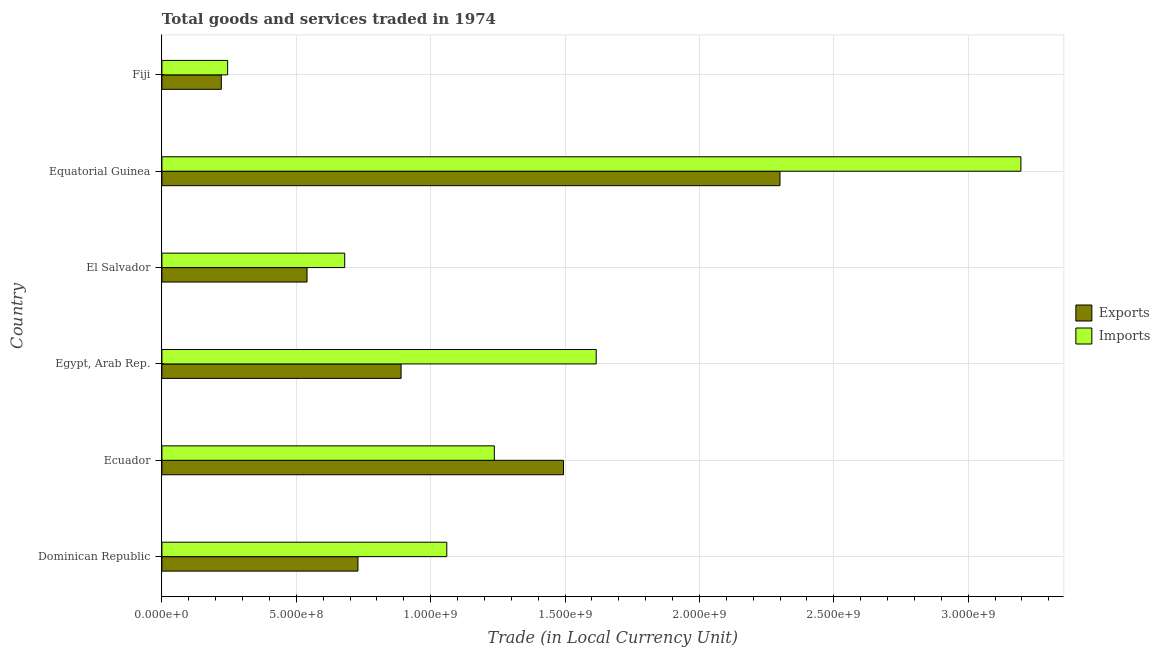How many groups of bars are there?
Make the answer very short. 6. Are the number of bars per tick equal to the number of legend labels?
Offer a terse response. Yes. Are the number of bars on each tick of the Y-axis equal?
Your answer should be very brief. Yes. How many bars are there on the 3rd tick from the bottom?
Provide a short and direct response. 2. What is the label of the 5th group of bars from the top?
Give a very brief answer. Ecuador. What is the export of goods and services in Ecuador?
Your answer should be very brief. 1.49e+09. Across all countries, what is the maximum imports of goods and services?
Offer a very short reply. 3.20e+09. Across all countries, what is the minimum imports of goods and services?
Keep it short and to the point. 2.45e+08. In which country was the export of goods and services maximum?
Provide a succinct answer. Equatorial Guinea. In which country was the imports of goods and services minimum?
Provide a short and direct response. Fiji. What is the total export of goods and services in the graph?
Offer a terse response. 6.17e+09. What is the difference between the imports of goods and services in Egypt, Arab Rep. and that in El Salvador?
Provide a short and direct response. 9.36e+08. What is the difference between the imports of goods and services in Equatorial Guinea and the export of goods and services in El Salvador?
Provide a succinct answer. 2.66e+09. What is the average export of goods and services per country?
Make the answer very short. 1.03e+09. What is the difference between the export of goods and services and imports of goods and services in Dominican Republic?
Give a very brief answer. -3.30e+08. What is the ratio of the export of goods and services in Egypt, Arab Rep. to that in Fiji?
Provide a succinct answer. 4.03. What is the difference between the highest and the second highest export of goods and services?
Make the answer very short. 8.06e+08. What is the difference between the highest and the lowest imports of goods and services?
Provide a succinct answer. 2.95e+09. What does the 2nd bar from the top in Equatorial Guinea represents?
Offer a very short reply. Exports. What does the 1st bar from the bottom in El Salvador represents?
Keep it short and to the point. Exports. How many bars are there?
Your response must be concise. 12. How many countries are there in the graph?
Offer a terse response. 6. What is the difference between two consecutive major ticks on the X-axis?
Ensure brevity in your answer.  5.00e+08. Are the values on the major ticks of X-axis written in scientific E-notation?
Offer a terse response. Yes. Does the graph contain grids?
Your answer should be very brief. Yes. Where does the legend appear in the graph?
Make the answer very short. Center right. How many legend labels are there?
Keep it short and to the point. 2. What is the title of the graph?
Your answer should be very brief. Total goods and services traded in 1974. What is the label or title of the X-axis?
Keep it short and to the point. Trade (in Local Currency Unit). What is the Trade (in Local Currency Unit) of Exports in Dominican Republic?
Your answer should be very brief. 7.30e+08. What is the Trade (in Local Currency Unit) of Imports in Dominican Republic?
Make the answer very short. 1.06e+09. What is the Trade (in Local Currency Unit) in Exports in Ecuador?
Keep it short and to the point. 1.49e+09. What is the Trade (in Local Currency Unit) of Imports in Ecuador?
Make the answer very short. 1.24e+09. What is the Trade (in Local Currency Unit) of Exports in Egypt, Arab Rep.?
Keep it short and to the point. 8.90e+08. What is the Trade (in Local Currency Unit) of Imports in Egypt, Arab Rep.?
Offer a very short reply. 1.62e+09. What is the Trade (in Local Currency Unit) of Exports in El Salvador?
Make the answer very short. 5.40e+08. What is the Trade (in Local Currency Unit) of Imports in El Salvador?
Your answer should be very brief. 6.80e+08. What is the Trade (in Local Currency Unit) of Exports in Equatorial Guinea?
Keep it short and to the point. 2.30e+09. What is the Trade (in Local Currency Unit) in Imports in Equatorial Guinea?
Make the answer very short. 3.20e+09. What is the Trade (in Local Currency Unit) of Exports in Fiji?
Ensure brevity in your answer.  2.21e+08. What is the Trade (in Local Currency Unit) in Imports in Fiji?
Your answer should be very brief. 2.45e+08. Across all countries, what is the maximum Trade (in Local Currency Unit) of Exports?
Give a very brief answer. 2.30e+09. Across all countries, what is the maximum Trade (in Local Currency Unit) of Imports?
Your answer should be compact. 3.20e+09. Across all countries, what is the minimum Trade (in Local Currency Unit) of Exports?
Make the answer very short. 2.21e+08. Across all countries, what is the minimum Trade (in Local Currency Unit) in Imports?
Your answer should be compact. 2.45e+08. What is the total Trade (in Local Currency Unit) in Exports in the graph?
Your answer should be compact. 6.17e+09. What is the total Trade (in Local Currency Unit) of Imports in the graph?
Provide a short and direct response. 8.03e+09. What is the difference between the Trade (in Local Currency Unit) of Exports in Dominican Republic and that in Ecuador?
Your answer should be compact. -7.65e+08. What is the difference between the Trade (in Local Currency Unit) in Imports in Dominican Republic and that in Ecuador?
Give a very brief answer. -1.77e+08. What is the difference between the Trade (in Local Currency Unit) of Exports in Dominican Republic and that in Egypt, Arab Rep.?
Ensure brevity in your answer.  -1.60e+08. What is the difference between the Trade (in Local Currency Unit) in Imports in Dominican Republic and that in Egypt, Arab Rep.?
Keep it short and to the point. -5.56e+08. What is the difference between the Trade (in Local Currency Unit) of Exports in Dominican Republic and that in El Salvador?
Your response must be concise. 1.89e+08. What is the difference between the Trade (in Local Currency Unit) in Imports in Dominican Republic and that in El Salvador?
Ensure brevity in your answer.  3.80e+08. What is the difference between the Trade (in Local Currency Unit) in Exports in Dominican Republic and that in Equatorial Guinea?
Your answer should be very brief. -1.57e+09. What is the difference between the Trade (in Local Currency Unit) in Imports in Dominican Republic and that in Equatorial Guinea?
Provide a succinct answer. -2.14e+09. What is the difference between the Trade (in Local Currency Unit) in Exports in Dominican Republic and that in Fiji?
Provide a short and direct response. 5.08e+08. What is the difference between the Trade (in Local Currency Unit) of Imports in Dominican Republic and that in Fiji?
Give a very brief answer. 8.15e+08. What is the difference between the Trade (in Local Currency Unit) in Exports in Ecuador and that in Egypt, Arab Rep.?
Offer a very short reply. 6.04e+08. What is the difference between the Trade (in Local Currency Unit) in Imports in Ecuador and that in Egypt, Arab Rep.?
Your answer should be compact. -3.79e+08. What is the difference between the Trade (in Local Currency Unit) in Exports in Ecuador and that in El Salvador?
Make the answer very short. 9.54e+08. What is the difference between the Trade (in Local Currency Unit) of Imports in Ecuador and that in El Salvador?
Give a very brief answer. 5.57e+08. What is the difference between the Trade (in Local Currency Unit) in Exports in Ecuador and that in Equatorial Guinea?
Provide a succinct answer. -8.06e+08. What is the difference between the Trade (in Local Currency Unit) in Imports in Ecuador and that in Equatorial Guinea?
Your response must be concise. -1.96e+09. What is the difference between the Trade (in Local Currency Unit) in Exports in Ecuador and that in Fiji?
Your answer should be compact. 1.27e+09. What is the difference between the Trade (in Local Currency Unit) of Imports in Ecuador and that in Fiji?
Give a very brief answer. 9.92e+08. What is the difference between the Trade (in Local Currency Unit) of Exports in Egypt, Arab Rep. and that in El Salvador?
Ensure brevity in your answer.  3.50e+08. What is the difference between the Trade (in Local Currency Unit) in Imports in Egypt, Arab Rep. and that in El Salvador?
Offer a very short reply. 9.36e+08. What is the difference between the Trade (in Local Currency Unit) in Exports in Egypt, Arab Rep. and that in Equatorial Guinea?
Make the answer very short. -1.41e+09. What is the difference between the Trade (in Local Currency Unit) in Imports in Egypt, Arab Rep. and that in Equatorial Guinea?
Offer a very short reply. -1.58e+09. What is the difference between the Trade (in Local Currency Unit) of Exports in Egypt, Arab Rep. and that in Fiji?
Ensure brevity in your answer.  6.69e+08. What is the difference between the Trade (in Local Currency Unit) in Imports in Egypt, Arab Rep. and that in Fiji?
Provide a short and direct response. 1.37e+09. What is the difference between the Trade (in Local Currency Unit) in Exports in El Salvador and that in Equatorial Guinea?
Your response must be concise. -1.76e+09. What is the difference between the Trade (in Local Currency Unit) of Imports in El Salvador and that in Equatorial Guinea?
Offer a very short reply. -2.52e+09. What is the difference between the Trade (in Local Currency Unit) of Exports in El Salvador and that in Fiji?
Offer a terse response. 3.19e+08. What is the difference between the Trade (in Local Currency Unit) in Imports in El Salvador and that in Fiji?
Your response must be concise. 4.36e+08. What is the difference between the Trade (in Local Currency Unit) of Exports in Equatorial Guinea and that in Fiji?
Offer a very short reply. 2.08e+09. What is the difference between the Trade (in Local Currency Unit) in Imports in Equatorial Guinea and that in Fiji?
Keep it short and to the point. 2.95e+09. What is the difference between the Trade (in Local Currency Unit) of Exports in Dominican Republic and the Trade (in Local Currency Unit) of Imports in Ecuador?
Provide a succinct answer. -5.07e+08. What is the difference between the Trade (in Local Currency Unit) of Exports in Dominican Republic and the Trade (in Local Currency Unit) of Imports in Egypt, Arab Rep.?
Make the answer very short. -8.86e+08. What is the difference between the Trade (in Local Currency Unit) in Exports in Dominican Republic and the Trade (in Local Currency Unit) in Imports in El Salvador?
Make the answer very short. 4.93e+07. What is the difference between the Trade (in Local Currency Unit) in Exports in Dominican Republic and the Trade (in Local Currency Unit) in Imports in Equatorial Guinea?
Make the answer very short. -2.47e+09. What is the difference between the Trade (in Local Currency Unit) of Exports in Dominican Republic and the Trade (in Local Currency Unit) of Imports in Fiji?
Ensure brevity in your answer.  4.85e+08. What is the difference between the Trade (in Local Currency Unit) in Exports in Ecuador and the Trade (in Local Currency Unit) in Imports in Egypt, Arab Rep.?
Keep it short and to the point. -1.22e+08. What is the difference between the Trade (in Local Currency Unit) in Exports in Ecuador and the Trade (in Local Currency Unit) in Imports in El Salvador?
Offer a very short reply. 8.14e+08. What is the difference between the Trade (in Local Currency Unit) in Exports in Ecuador and the Trade (in Local Currency Unit) in Imports in Equatorial Guinea?
Offer a terse response. -1.70e+09. What is the difference between the Trade (in Local Currency Unit) of Exports in Ecuador and the Trade (in Local Currency Unit) of Imports in Fiji?
Ensure brevity in your answer.  1.25e+09. What is the difference between the Trade (in Local Currency Unit) in Exports in Egypt, Arab Rep. and the Trade (in Local Currency Unit) in Imports in El Salvador?
Provide a succinct answer. 2.10e+08. What is the difference between the Trade (in Local Currency Unit) of Exports in Egypt, Arab Rep. and the Trade (in Local Currency Unit) of Imports in Equatorial Guinea?
Offer a very short reply. -2.31e+09. What is the difference between the Trade (in Local Currency Unit) in Exports in Egypt, Arab Rep. and the Trade (in Local Currency Unit) in Imports in Fiji?
Make the answer very short. 6.45e+08. What is the difference between the Trade (in Local Currency Unit) in Exports in El Salvador and the Trade (in Local Currency Unit) in Imports in Equatorial Guinea?
Provide a succinct answer. -2.66e+09. What is the difference between the Trade (in Local Currency Unit) in Exports in El Salvador and the Trade (in Local Currency Unit) in Imports in Fiji?
Offer a very short reply. 2.95e+08. What is the difference between the Trade (in Local Currency Unit) in Exports in Equatorial Guinea and the Trade (in Local Currency Unit) in Imports in Fiji?
Your answer should be compact. 2.06e+09. What is the average Trade (in Local Currency Unit) of Exports per country?
Make the answer very short. 1.03e+09. What is the average Trade (in Local Currency Unit) of Imports per country?
Offer a terse response. 1.34e+09. What is the difference between the Trade (in Local Currency Unit) of Exports and Trade (in Local Currency Unit) of Imports in Dominican Republic?
Give a very brief answer. -3.30e+08. What is the difference between the Trade (in Local Currency Unit) in Exports and Trade (in Local Currency Unit) in Imports in Ecuador?
Keep it short and to the point. 2.57e+08. What is the difference between the Trade (in Local Currency Unit) in Exports and Trade (in Local Currency Unit) in Imports in Egypt, Arab Rep.?
Your answer should be compact. -7.26e+08. What is the difference between the Trade (in Local Currency Unit) of Exports and Trade (in Local Currency Unit) of Imports in El Salvador?
Give a very brief answer. -1.40e+08. What is the difference between the Trade (in Local Currency Unit) of Exports and Trade (in Local Currency Unit) of Imports in Equatorial Guinea?
Keep it short and to the point. -8.96e+08. What is the difference between the Trade (in Local Currency Unit) of Exports and Trade (in Local Currency Unit) of Imports in Fiji?
Keep it short and to the point. -2.35e+07. What is the ratio of the Trade (in Local Currency Unit) in Exports in Dominican Republic to that in Ecuador?
Your answer should be very brief. 0.49. What is the ratio of the Trade (in Local Currency Unit) of Imports in Dominican Republic to that in Ecuador?
Make the answer very short. 0.86. What is the ratio of the Trade (in Local Currency Unit) of Exports in Dominican Republic to that in Egypt, Arab Rep.?
Give a very brief answer. 0.82. What is the ratio of the Trade (in Local Currency Unit) in Imports in Dominican Republic to that in Egypt, Arab Rep.?
Give a very brief answer. 0.66. What is the ratio of the Trade (in Local Currency Unit) in Exports in Dominican Republic to that in El Salvador?
Make the answer very short. 1.35. What is the ratio of the Trade (in Local Currency Unit) in Imports in Dominican Republic to that in El Salvador?
Your answer should be very brief. 1.56. What is the ratio of the Trade (in Local Currency Unit) of Exports in Dominican Republic to that in Equatorial Guinea?
Make the answer very short. 0.32. What is the ratio of the Trade (in Local Currency Unit) in Imports in Dominican Republic to that in Equatorial Guinea?
Offer a terse response. 0.33. What is the ratio of the Trade (in Local Currency Unit) in Exports in Dominican Republic to that in Fiji?
Ensure brevity in your answer.  3.3. What is the ratio of the Trade (in Local Currency Unit) in Imports in Dominican Republic to that in Fiji?
Give a very brief answer. 4.33. What is the ratio of the Trade (in Local Currency Unit) of Exports in Ecuador to that in Egypt, Arab Rep.?
Your answer should be compact. 1.68. What is the ratio of the Trade (in Local Currency Unit) in Imports in Ecuador to that in Egypt, Arab Rep.?
Make the answer very short. 0.77. What is the ratio of the Trade (in Local Currency Unit) of Exports in Ecuador to that in El Salvador?
Provide a succinct answer. 2.77. What is the ratio of the Trade (in Local Currency Unit) in Imports in Ecuador to that in El Salvador?
Ensure brevity in your answer.  1.82. What is the ratio of the Trade (in Local Currency Unit) in Exports in Ecuador to that in Equatorial Guinea?
Ensure brevity in your answer.  0.65. What is the ratio of the Trade (in Local Currency Unit) in Imports in Ecuador to that in Equatorial Guinea?
Your answer should be compact. 0.39. What is the ratio of the Trade (in Local Currency Unit) in Exports in Ecuador to that in Fiji?
Your answer should be very brief. 6.76. What is the ratio of the Trade (in Local Currency Unit) of Imports in Ecuador to that in Fiji?
Ensure brevity in your answer.  5.06. What is the ratio of the Trade (in Local Currency Unit) of Exports in Egypt, Arab Rep. to that in El Salvador?
Provide a succinct answer. 1.65. What is the ratio of the Trade (in Local Currency Unit) of Imports in Egypt, Arab Rep. to that in El Salvador?
Make the answer very short. 2.38. What is the ratio of the Trade (in Local Currency Unit) of Exports in Egypt, Arab Rep. to that in Equatorial Guinea?
Ensure brevity in your answer.  0.39. What is the ratio of the Trade (in Local Currency Unit) in Imports in Egypt, Arab Rep. to that in Equatorial Guinea?
Give a very brief answer. 0.51. What is the ratio of the Trade (in Local Currency Unit) in Exports in Egypt, Arab Rep. to that in Fiji?
Ensure brevity in your answer.  4.03. What is the ratio of the Trade (in Local Currency Unit) of Imports in Egypt, Arab Rep. to that in Fiji?
Provide a succinct answer. 6.61. What is the ratio of the Trade (in Local Currency Unit) of Exports in El Salvador to that in Equatorial Guinea?
Provide a short and direct response. 0.23. What is the ratio of the Trade (in Local Currency Unit) in Imports in El Salvador to that in Equatorial Guinea?
Ensure brevity in your answer.  0.21. What is the ratio of the Trade (in Local Currency Unit) in Exports in El Salvador to that in Fiji?
Provide a short and direct response. 2.44. What is the ratio of the Trade (in Local Currency Unit) in Imports in El Salvador to that in Fiji?
Offer a terse response. 2.78. What is the ratio of the Trade (in Local Currency Unit) in Exports in Equatorial Guinea to that in Fiji?
Your response must be concise. 10.4. What is the ratio of the Trade (in Local Currency Unit) in Imports in Equatorial Guinea to that in Fiji?
Keep it short and to the point. 13.07. What is the difference between the highest and the second highest Trade (in Local Currency Unit) in Exports?
Provide a short and direct response. 8.06e+08. What is the difference between the highest and the second highest Trade (in Local Currency Unit) of Imports?
Make the answer very short. 1.58e+09. What is the difference between the highest and the lowest Trade (in Local Currency Unit) in Exports?
Offer a very short reply. 2.08e+09. What is the difference between the highest and the lowest Trade (in Local Currency Unit) of Imports?
Ensure brevity in your answer.  2.95e+09. 